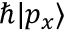<formula> <loc_0><loc_0><loc_500><loc_500>\hbar { | } p _ { x } \rangle</formula> 